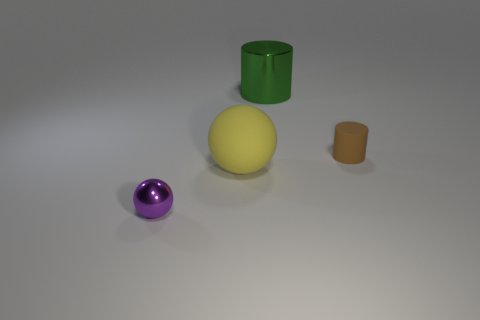What time of day does the lighting in this image suggest? The lighting in the image doesn't strongly suggest any particular time of day as it appears to be neutral and artificial, akin to what you might find in a controlled indoor setting, such as a photography studio.  Could that mean these objects are being presented for a specific reason? Yes, the neutral lighting and plain background often indicate that the objects are being highlighted for examination, possibly for educational purposes, marketing, or a display that focuses attention on their shapes and colors. 